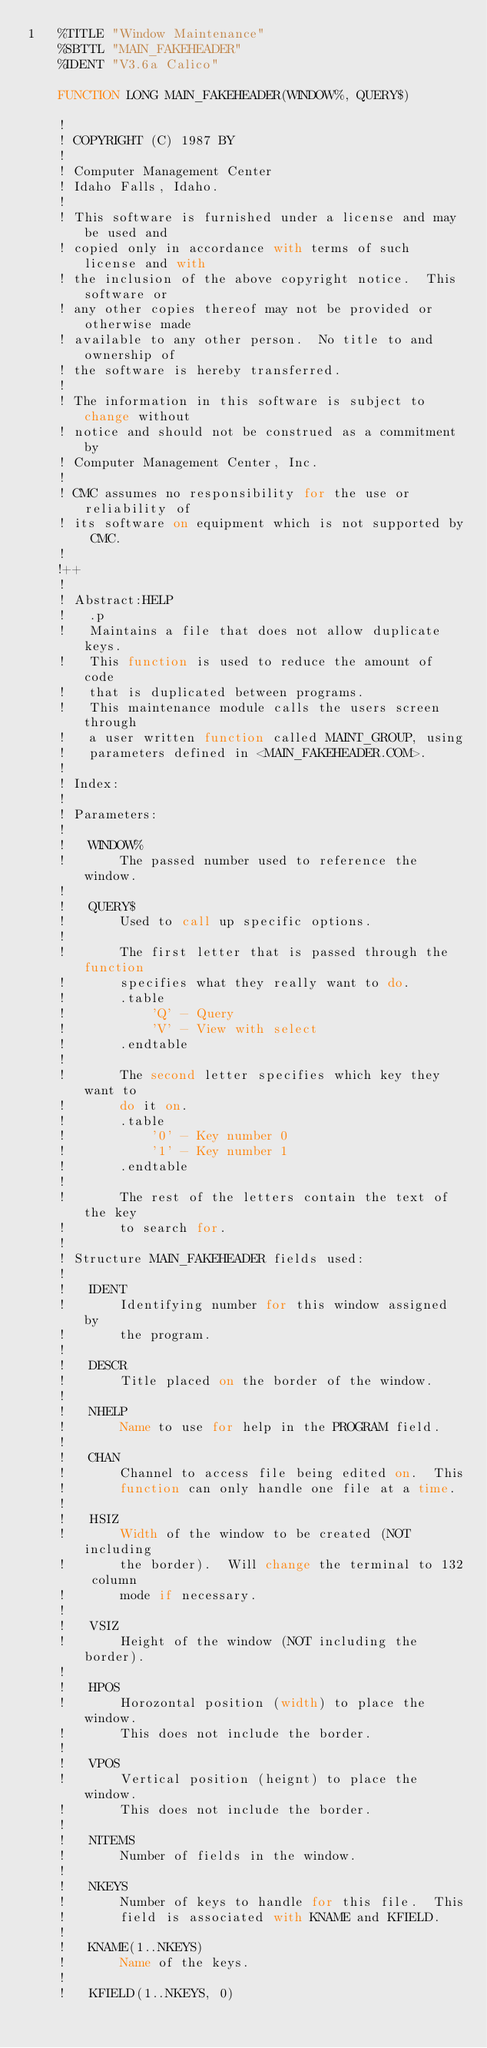Convert code to text. <code><loc_0><loc_0><loc_500><loc_500><_VisualBasic_>1	%TITLE "Window Maintenance"
	%SBTTL "MAIN_FAKEHEADER"
	%IDENT "V3.6a Calico"

	FUNCTION LONG MAIN_FAKEHEADER(WINDOW%, QUERY$)

	!
	! COPYRIGHT (C) 1987 BY
	!
	! Computer Management Center
	! Idaho Falls, Idaho.
	!
	! This software is furnished under a license and may be used and
	! copied only in accordance with terms of such license and with
	! the inclusion of the above copyright notice.  This software or
	! any other copies thereof may not be provided or otherwise made
	! available to any other person.  No title to and ownership of
	! the software is hereby transferred.
	!
	! The information in this software is subject to change without
	! notice and should not be construed as a commitment by
	! Computer Management Center, Inc.
	!
	! CMC assumes no responsibility for the use or reliability of
	! its software on equipment which is not supported by CMC.
	!
	!++
	!
	! Abstract:HELP
	!	.p
	!	Maintains a file that does not allow duplicate keys.
	!	This function is used to reduce the amount of code
	!	that is duplicated between programs.
	!	This maintenance module calls the users screen through
	!	a user written function called MAINT_GROUP, using
	!	parameters defined in <MAIN_FAKEHEADER.COM>.
	!
	! Index:
	!
	! Parameters:
	!
	!	WINDOW%
	!		The passed number used to reference the window.
	!
	!	QUERY$
	!		Used to call up specific options.
	!
	!		The first letter that is passed through the function
	!		specifies what they really want to do.
	!		.table
	!			'Q' - Query
	!			'V' - View with select
	!		.endtable
	!
	!		The second letter specifies which key they want to
	!		do it on.
	!		.table
	!			'0' - Key number 0
	!			'1' - Key number 1
	!		.endtable
	!
	!		The rest of the letters contain the text of the key
	!		to search for.
	!
	! Structure MAIN_FAKEHEADER fields used:
	!
	!	IDENT
	!		Identifying number for this window assigned by
	!		the program.
	!
	!	DESCR
	!		Title placed on the border of the window.
	!
	!	NHELP
	!		Name to use for help in the PROGRAM field.
	!
	!	CHAN
	!		Channel to access file being edited on.  This
	!		function can only handle one file at a time.
	!
	!	HSIZ
	!		Width of the window to be created (NOT including
	!		the border).  Will change the terminal to 132 column
	!		mode if necessary.
	!
	!	VSIZ
	!		Height of the window (NOT including the border).
	!
	!	HPOS
	!		Horozontal position (width) to place the window.
	!		This does not include the border.
	!
	!	VPOS
	!		Vertical position (heignt) to place the window.
	!		This does not include the border.
	!
	!	NITEMS
	!		Number of fields in the window.
	!
	!	NKEYS
	!		Number of keys to handle for this file.  This
	!		field is associated with KNAME and KFIELD.
	!
	!	KNAME(1..NKEYS)
	!		Name of the keys.
	!
	!	KFIELD(1..NKEYS, 0)</code> 